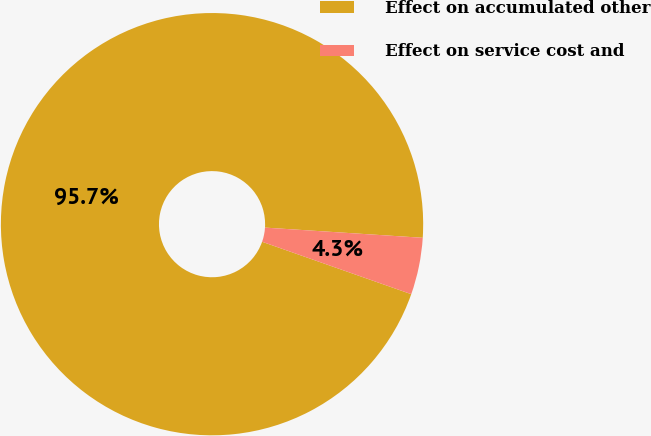Convert chart. <chart><loc_0><loc_0><loc_500><loc_500><pie_chart><fcel>Effect on accumulated other<fcel>Effect on service cost and<nl><fcel>95.65%<fcel>4.35%<nl></chart> 